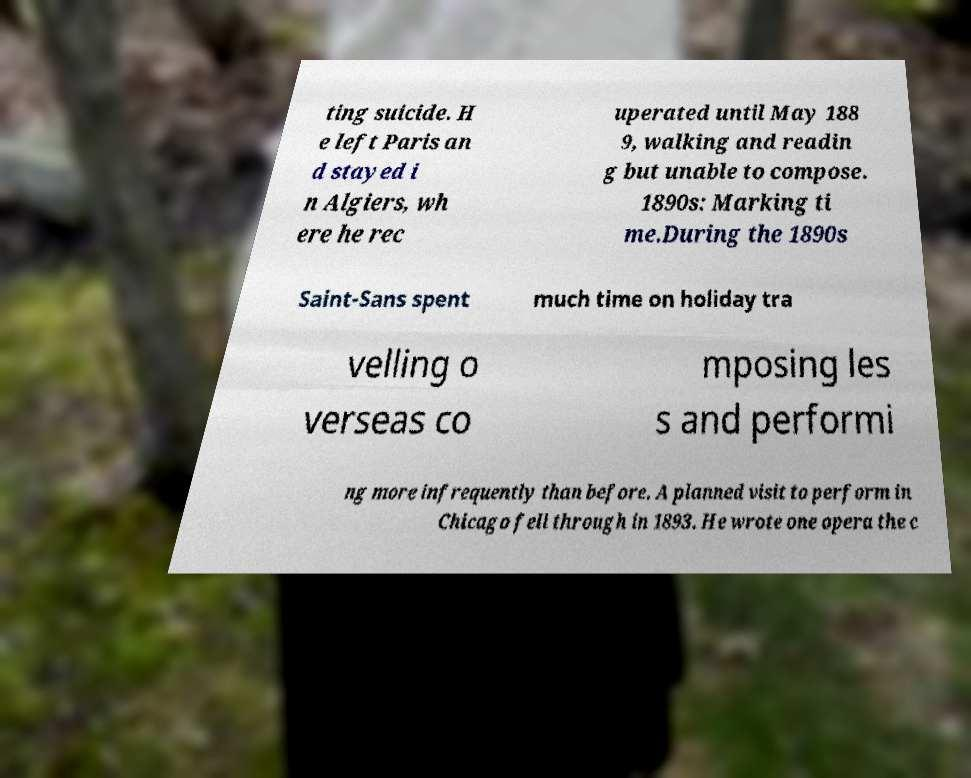What messages or text are displayed in this image? I need them in a readable, typed format. ting suicide. H e left Paris an d stayed i n Algiers, wh ere he rec uperated until May 188 9, walking and readin g but unable to compose. 1890s: Marking ti me.During the 1890s Saint-Sans spent much time on holiday tra velling o verseas co mposing les s and performi ng more infrequently than before. A planned visit to perform in Chicago fell through in 1893. He wrote one opera the c 